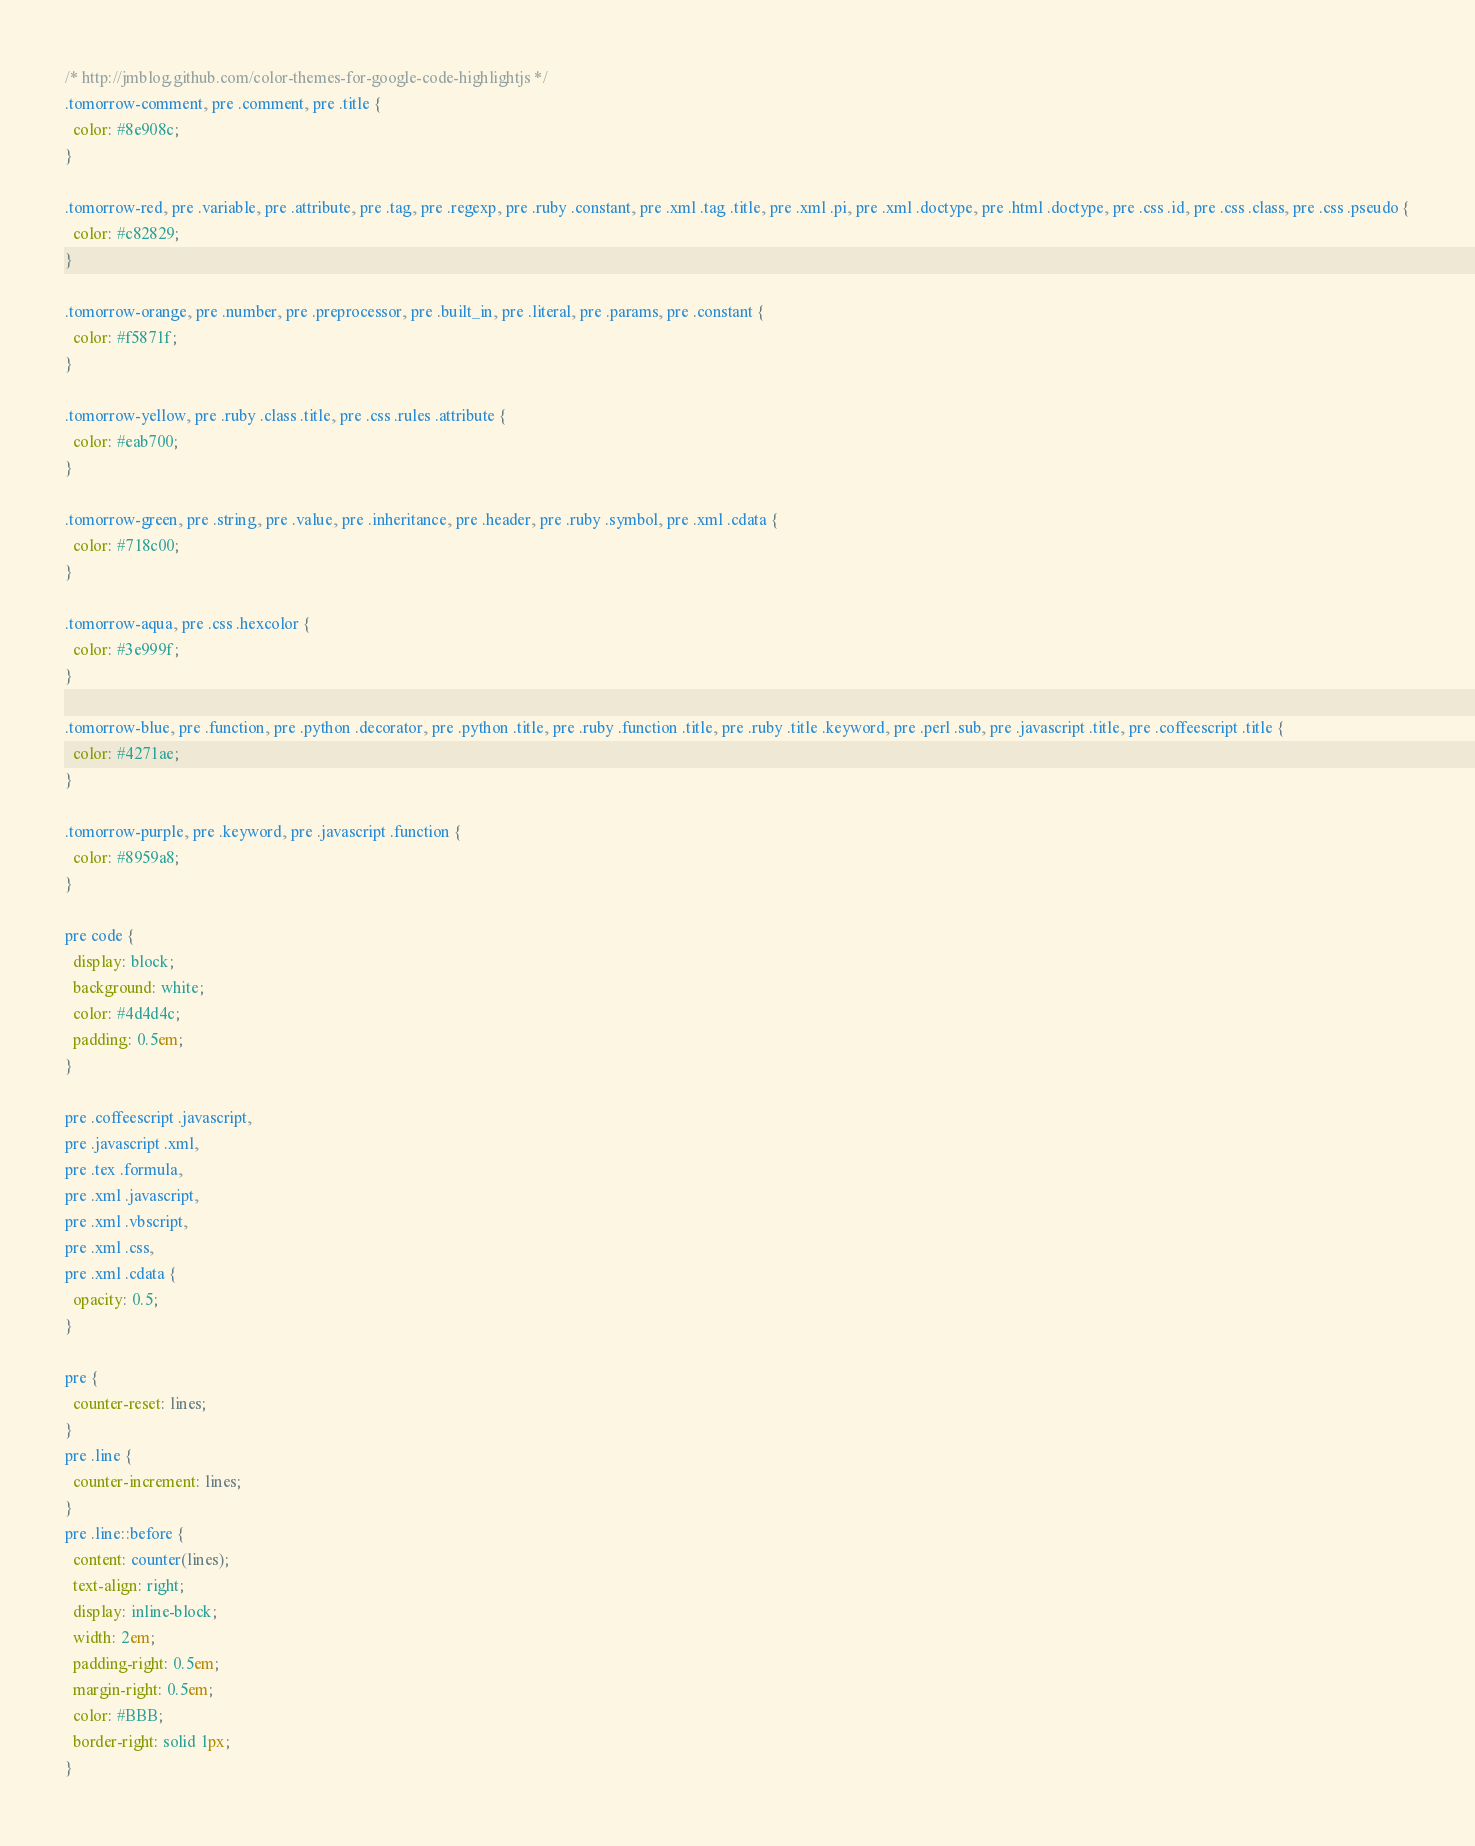Convert code to text. <code><loc_0><loc_0><loc_500><loc_500><_CSS_>/* http://jmblog.github.com/color-themes-for-google-code-highlightjs */
.tomorrow-comment, pre .comment, pre .title {
  color: #8e908c;
}

.tomorrow-red, pre .variable, pre .attribute, pre .tag, pre .regexp, pre .ruby .constant, pre .xml .tag .title, pre .xml .pi, pre .xml .doctype, pre .html .doctype, pre .css .id, pre .css .class, pre .css .pseudo {
  color: #c82829;
}

.tomorrow-orange, pre .number, pre .preprocessor, pre .built_in, pre .literal, pre .params, pre .constant {
  color: #f5871f;
}

.tomorrow-yellow, pre .ruby .class .title, pre .css .rules .attribute {
  color: #eab700;
}

.tomorrow-green, pre .string, pre .value, pre .inheritance, pre .header, pre .ruby .symbol, pre .xml .cdata {
  color: #718c00;
}

.tomorrow-aqua, pre .css .hexcolor {
  color: #3e999f;
}

.tomorrow-blue, pre .function, pre .python .decorator, pre .python .title, pre .ruby .function .title, pre .ruby .title .keyword, pre .perl .sub, pre .javascript .title, pre .coffeescript .title {
  color: #4271ae;
}

.tomorrow-purple, pre .keyword, pre .javascript .function {
  color: #8959a8;
}

pre code {
  display: block;
  background: white;
  color: #4d4d4c;
  padding: 0.5em;
}

pre .coffeescript .javascript,
pre .javascript .xml,
pre .tex .formula,
pre .xml .javascript,
pre .xml .vbscript,
pre .xml .css,
pre .xml .cdata {
  opacity: 0.5;
}

pre {
  counter-reset: lines;
}
pre .line {
  counter-increment: lines;
}
pre .line::before {
  content: counter(lines); 
  text-align: right;
  display: inline-block; 
  width: 2em;
  padding-right: 0.5em; 
  margin-right: 0.5em;
  color: #BBB; 
  border-right: solid 1px;
}

</code> 